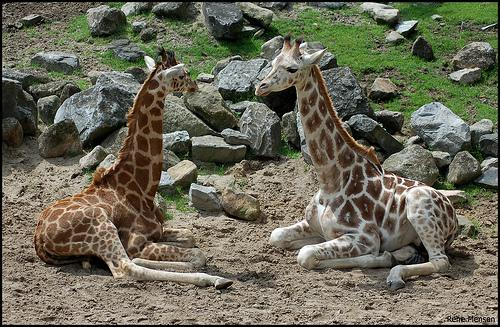Question: how many giraffes are there?
Choices:
A. Four.
B. One.
C. Two.
D. Six.
Answer with the letter. Answer: C Question: when was the photo taken?
Choices:
A. In the morning.
B. Daytime.
C. At midnight.
D. At 3:30.
Answer with the letter. Answer: B Question: what is next to the animals?
Choices:
A. Rocks.
B. The barn.
C. The children.
D. The garden.
Answer with the letter. Answer: A Question: what kind of animals are they?
Choices:
A. Birds.
B. Horses.
C. Giraffes.
D. Dogs.
Answer with the letter. Answer: C Question: where are the giraffes?
Choices:
A. In a field.
B. In the barn.
C. Africa.
D. At a zoo.
Answer with the letter. Answer: D 